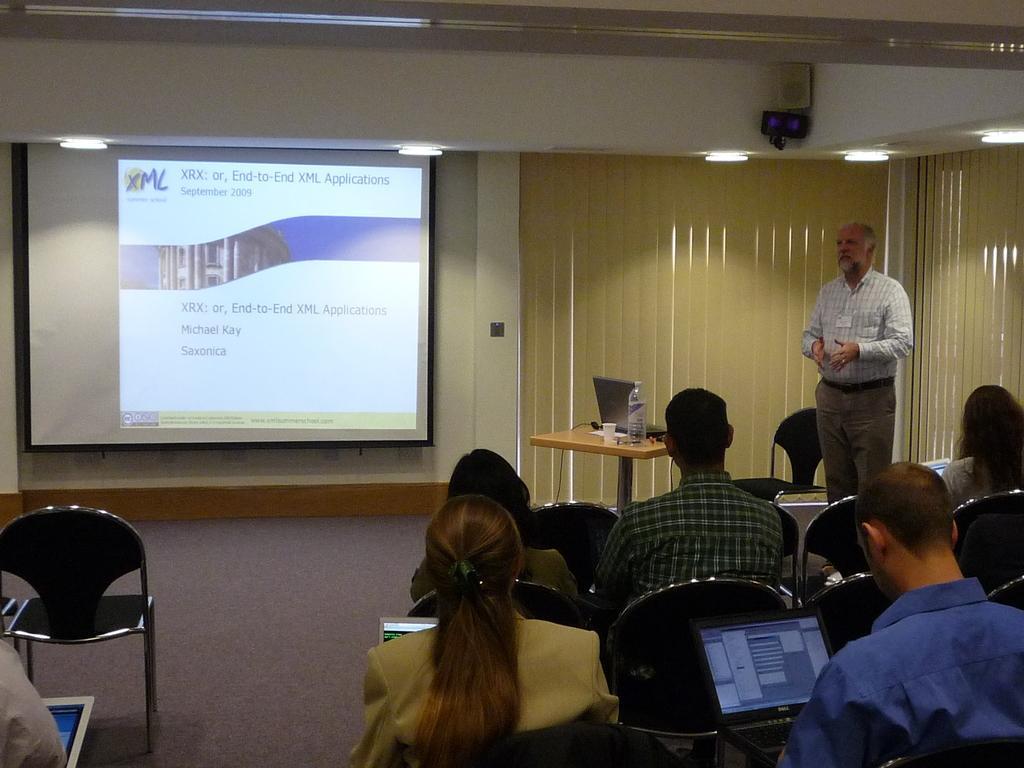In one or two sentences, can you explain what this image depicts? This image is clicked inside a room. There are window blinds in the middle. There are chairs in the middle and people are sitting in that chairs. There is a screen on the left side. There is a man standing on the right side. There are lights at the top. There is a table in the middle, on that there are water bottle, cup, laptop. 